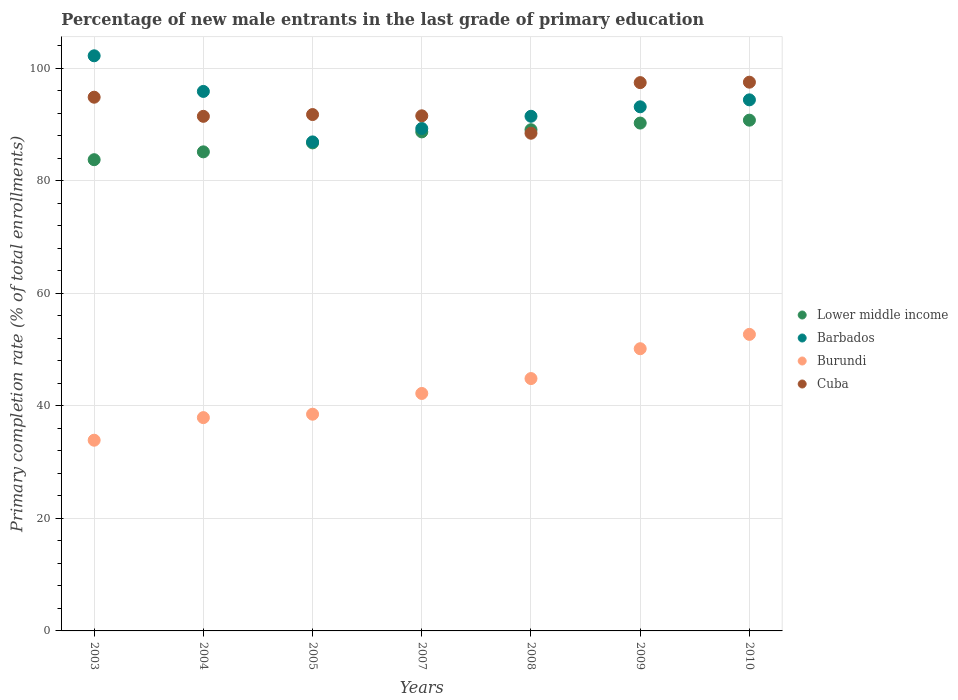Is the number of dotlines equal to the number of legend labels?
Your response must be concise. Yes. What is the percentage of new male entrants in Burundi in 2003?
Offer a terse response. 33.89. Across all years, what is the maximum percentage of new male entrants in Lower middle income?
Keep it short and to the point. 90.78. Across all years, what is the minimum percentage of new male entrants in Burundi?
Your answer should be very brief. 33.89. In which year was the percentage of new male entrants in Lower middle income minimum?
Offer a terse response. 2003. What is the total percentage of new male entrants in Burundi in the graph?
Keep it short and to the point. 300.24. What is the difference between the percentage of new male entrants in Burundi in 2003 and that in 2010?
Offer a very short reply. -18.81. What is the difference between the percentage of new male entrants in Lower middle income in 2004 and the percentage of new male entrants in Burundi in 2009?
Provide a short and direct response. 34.99. What is the average percentage of new male entrants in Lower middle income per year?
Your response must be concise. 87.78. In the year 2010, what is the difference between the percentage of new male entrants in Cuba and percentage of new male entrants in Barbados?
Ensure brevity in your answer.  3.14. What is the ratio of the percentage of new male entrants in Barbados in 2003 to that in 2005?
Offer a terse response. 1.18. Is the percentage of new male entrants in Lower middle income in 2009 less than that in 2010?
Keep it short and to the point. Yes. Is the difference between the percentage of new male entrants in Cuba in 2008 and 2009 greater than the difference between the percentage of new male entrants in Barbados in 2008 and 2009?
Make the answer very short. No. What is the difference between the highest and the second highest percentage of new male entrants in Barbados?
Your answer should be compact. 6.33. What is the difference between the highest and the lowest percentage of new male entrants in Lower middle income?
Provide a short and direct response. 7.03. In how many years, is the percentage of new male entrants in Cuba greater than the average percentage of new male entrants in Cuba taken over all years?
Your answer should be very brief. 3. Is the sum of the percentage of new male entrants in Barbados in 2007 and 2009 greater than the maximum percentage of new male entrants in Burundi across all years?
Provide a succinct answer. Yes. Is it the case that in every year, the sum of the percentage of new male entrants in Cuba and percentage of new male entrants in Barbados  is greater than the sum of percentage of new male entrants in Burundi and percentage of new male entrants in Lower middle income?
Provide a succinct answer. No. Is the percentage of new male entrants in Cuba strictly less than the percentage of new male entrants in Lower middle income over the years?
Provide a short and direct response. No. What is the difference between two consecutive major ticks on the Y-axis?
Give a very brief answer. 20. How many legend labels are there?
Your response must be concise. 4. How are the legend labels stacked?
Your answer should be compact. Vertical. What is the title of the graph?
Make the answer very short. Percentage of new male entrants in the last grade of primary education. What is the label or title of the X-axis?
Your response must be concise. Years. What is the label or title of the Y-axis?
Provide a succinct answer. Primary completion rate (% of total enrollments). What is the Primary completion rate (% of total enrollments) of Lower middle income in 2003?
Make the answer very short. 83.75. What is the Primary completion rate (% of total enrollments) in Barbados in 2003?
Ensure brevity in your answer.  102.22. What is the Primary completion rate (% of total enrollments) of Burundi in 2003?
Provide a succinct answer. 33.89. What is the Primary completion rate (% of total enrollments) of Cuba in 2003?
Provide a succinct answer. 94.86. What is the Primary completion rate (% of total enrollments) in Lower middle income in 2004?
Make the answer very short. 85.15. What is the Primary completion rate (% of total enrollments) in Barbados in 2004?
Provide a succinct answer. 95.89. What is the Primary completion rate (% of total enrollments) in Burundi in 2004?
Provide a succinct answer. 37.91. What is the Primary completion rate (% of total enrollments) of Cuba in 2004?
Ensure brevity in your answer.  91.46. What is the Primary completion rate (% of total enrollments) of Lower middle income in 2005?
Your answer should be compact. 86.74. What is the Primary completion rate (% of total enrollments) of Barbados in 2005?
Give a very brief answer. 86.92. What is the Primary completion rate (% of total enrollments) in Burundi in 2005?
Provide a succinct answer. 38.52. What is the Primary completion rate (% of total enrollments) of Cuba in 2005?
Your response must be concise. 91.78. What is the Primary completion rate (% of total enrollments) of Lower middle income in 2007?
Provide a succinct answer. 88.69. What is the Primary completion rate (% of total enrollments) of Barbados in 2007?
Provide a succinct answer. 89.3. What is the Primary completion rate (% of total enrollments) in Burundi in 2007?
Keep it short and to the point. 42.21. What is the Primary completion rate (% of total enrollments) of Cuba in 2007?
Ensure brevity in your answer.  91.55. What is the Primary completion rate (% of total enrollments) in Lower middle income in 2008?
Your answer should be very brief. 89.08. What is the Primary completion rate (% of total enrollments) in Barbados in 2008?
Your answer should be very brief. 91.47. What is the Primary completion rate (% of total enrollments) of Burundi in 2008?
Provide a short and direct response. 44.85. What is the Primary completion rate (% of total enrollments) in Cuba in 2008?
Your answer should be compact. 88.46. What is the Primary completion rate (% of total enrollments) in Lower middle income in 2009?
Make the answer very short. 90.26. What is the Primary completion rate (% of total enrollments) of Barbados in 2009?
Ensure brevity in your answer.  93.15. What is the Primary completion rate (% of total enrollments) of Burundi in 2009?
Keep it short and to the point. 50.16. What is the Primary completion rate (% of total enrollments) of Cuba in 2009?
Keep it short and to the point. 97.45. What is the Primary completion rate (% of total enrollments) of Lower middle income in 2010?
Offer a very short reply. 90.78. What is the Primary completion rate (% of total enrollments) of Barbados in 2010?
Offer a terse response. 94.39. What is the Primary completion rate (% of total enrollments) in Burundi in 2010?
Your answer should be compact. 52.71. What is the Primary completion rate (% of total enrollments) in Cuba in 2010?
Provide a short and direct response. 97.53. Across all years, what is the maximum Primary completion rate (% of total enrollments) of Lower middle income?
Provide a succinct answer. 90.78. Across all years, what is the maximum Primary completion rate (% of total enrollments) in Barbados?
Give a very brief answer. 102.22. Across all years, what is the maximum Primary completion rate (% of total enrollments) of Burundi?
Your response must be concise. 52.71. Across all years, what is the maximum Primary completion rate (% of total enrollments) in Cuba?
Give a very brief answer. 97.53. Across all years, what is the minimum Primary completion rate (% of total enrollments) in Lower middle income?
Your answer should be very brief. 83.75. Across all years, what is the minimum Primary completion rate (% of total enrollments) of Barbados?
Make the answer very short. 86.92. Across all years, what is the minimum Primary completion rate (% of total enrollments) of Burundi?
Your answer should be very brief. 33.89. Across all years, what is the minimum Primary completion rate (% of total enrollments) of Cuba?
Provide a short and direct response. 88.46. What is the total Primary completion rate (% of total enrollments) of Lower middle income in the graph?
Provide a succinct answer. 614.46. What is the total Primary completion rate (% of total enrollments) in Barbados in the graph?
Give a very brief answer. 653.33. What is the total Primary completion rate (% of total enrollments) in Burundi in the graph?
Offer a terse response. 300.24. What is the total Primary completion rate (% of total enrollments) in Cuba in the graph?
Your answer should be compact. 653.08. What is the difference between the Primary completion rate (% of total enrollments) of Lower middle income in 2003 and that in 2004?
Keep it short and to the point. -1.39. What is the difference between the Primary completion rate (% of total enrollments) in Barbados in 2003 and that in 2004?
Provide a succinct answer. 6.33. What is the difference between the Primary completion rate (% of total enrollments) in Burundi in 2003 and that in 2004?
Make the answer very short. -4.02. What is the difference between the Primary completion rate (% of total enrollments) of Cuba in 2003 and that in 2004?
Ensure brevity in your answer.  3.4. What is the difference between the Primary completion rate (% of total enrollments) of Lower middle income in 2003 and that in 2005?
Your answer should be very brief. -2.99. What is the difference between the Primary completion rate (% of total enrollments) of Barbados in 2003 and that in 2005?
Offer a very short reply. 15.3. What is the difference between the Primary completion rate (% of total enrollments) of Burundi in 2003 and that in 2005?
Your response must be concise. -4.62. What is the difference between the Primary completion rate (% of total enrollments) in Cuba in 2003 and that in 2005?
Give a very brief answer. 3.08. What is the difference between the Primary completion rate (% of total enrollments) in Lower middle income in 2003 and that in 2007?
Provide a short and direct response. -4.94. What is the difference between the Primary completion rate (% of total enrollments) in Barbados in 2003 and that in 2007?
Give a very brief answer. 12.92. What is the difference between the Primary completion rate (% of total enrollments) of Burundi in 2003 and that in 2007?
Ensure brevity in your answer.  -8.31. What is the difference between the Primary completion rate (% of total enrollments) of Cuba in 2003 and that in 2007?
Offer a terse response. 3.31. What is the difference between the Primary completion rate (% of total enrollments) of Lower middle income in 2003 and that in 2008?
Your answer should be very brief. -5.33. What is the difference between the Primary completion rate (% of total enrollments) of Barbados in 2003 and that in 2008?
Your answer should be compact. 10.75. What is the difference between the Primary completion rate (% of total enrollments) of Burundi in 2003 and that in 2008?
Provide a succinct answer. -10.96. What is the difference between the Primary completion rate (% of total enrollments) in Cuba in 2003 and that in 2008?
Offer a very short reply. 6.4. What is the difference between the Primary completion rate (% of total enrollments) in Lower middle income in 2003 and that in 2009?
Ensure brevity in your answer.  -6.51. What is the difference between the Primary completion rate (% of total enrollments) in Barbados in 2003 and that in 2009?
Provide a succinct answer. 9.07. What is the difference between the Primary completion rate (% of total enrollments) of Burundi in 2003 and that in 2009?
Offer a terse response. -16.26. What is the difference between the Primary completion rate (% of total enrollments) of Cuba in 2003 and that in 2009?
Provide a short and direct response. -2.59. What is the difference between the Primary completion rate (% of total enrollments) of Lower middle income in 2003 and that in 2010?
Make the answer very short. -7.03. What is the difference between the Primary completion rate (% of total enrollments) in Barbados in 2003 and that in 2010?
Provide a succinct answer. 7.83. What is the difference between the Primary completion rate (% of total enrollments) of Burundi in 2003 and that in 2010?
Keep it short and to the point. -18.81. What is the difference between the Primary completion rate (% of total enrollments) in Cuba in 2003 and that in 2010?
Ensure brevity in your answer.  -2.67. What is the difference between the Primary completion rate (% of total enrollments) in Lower middle income in 2004 and that in 2005?
Ensure brevity in your answer.  -1.59. What is the difference between the Primary completion rate (% of total enrollments) in Barbados in 2004 and that in 2005?
Your answer should be very brief. 8.97. What is the difference between the Primary completion rate (% of total enrollments) of Burundi in 2004 and that in 2005?
Make the answer very short. -0.61. What is the difference between the Primary completion rate (% of total enrollments) of Cuba in 2004 and that in 2005?
Offer a terse response. -0.32. What is the difference between the Primary completion rate (% of total enrollments) of Lower middle income in 2004 and that in 2007?
Offer a terse response. -3.55. What is the difference between the Primary completion rate (% of total enrollments) in Barbados in 2004 and that in 2007?
Your response must be concise. 6.59. What is the difference between the Primary completion rate (% of total enrollments) of Burundi in 2004 and that in 2007?
Provide a succinct answer. -4.29. What is the difference between the Primary completion rate (% of total enrollments) in Cuba in 2004 and that in 2007?
Provide a short and direct response. -0.09. What is the difference between the Primary completion rate (% of total enrollments) in Lower middle income in 2004 and that in 2008?
Keep it short and to the point. -3.93. What is the difference between the Primary completion rate (% of total enrollments) of Barbados in 2004 and that in 2008?
Keep it short and to the point. 4.42. What is the difference between the Primary completion rate (% of total enrollments) of Burundi in 2004 and that in 2008?
Ensure brevity in your answer.  -6.94. What is the difference between the Primary completion rate (% of total enrollments) in Cuba in 2004 and that in 2008?
Offer a terse response. 3. What is the difference between the Primary completion rate (% of total enrollments) in Lower middle income in 2004 and that in 2009?
Ensure brevity in your answer.  -5.12. What is the difference between the Primary completion rate (% of total enrollments) in Barbados in 2004 and that in 2009?
Provide a succinct answer. 2.74. What is the difference between the Primary completion rate (% of total enrollments) in Burundi in 2004 and that in 2009?
Make the answer very short. -12.25. What is the difference between the Primary completion rate (% of total enrollments) in Cuba in 2004 and that in 2009?
Give a very brief answer. -5.99. What is the difference between the Primary completion rate (% of total enrollments) of Lower middle income in 2004 and that in 2010?
Keep it short and to the point. -5.63. What is the difference between the Primary completion rate (% of total enrollments) in Barbados in 2004 and that in 2010?
Provide a succinct answer. 1.5. What is the difference between the Primary completion rate (% of total enrollments) in Burundi in 2004 and that in 2010?
Offer a very short reply. -14.8. What is the difference between the Primary completion rate (% of total enrollments) of Cuba in 2004 and that in 2010?
Make the answer very short. -6.07. What is the difference between the Primary completion rate (% of total enrollments) of Lower middle income in 2005 and that in 2007?
Your response must be concise. -1.95. What is the difference between the Primary completion rate (% of total enrollments) in Barbados in 2005 and that in 2007?
Provide a succinct answer. -2.38. What is the difference between the Primary completion rate (% of total enrollments) of Burundi in 2005 and that in 2007?
Keep it short and to the point. -3.69. What is the difference between the Primary completion rate (% of total enrollments) in Cuba in 2005 and that in 2007?
Your response must be concise. 0.22. What is the difference between the Primary completion rate (% of total enrollments) of Lower middle income in 2005 and that in 2008?
Offer a terse response. -2.34. What is the difference between the Primary completion rate (% of total enrollments) in Barbados in 2005 and that in 2008?
Your response must be concise. -4.55. What is the difference between the Primary completion rate (% of total enrollments) of Burundi in 2005 and that in 2008?
Offer a very short reply. -6.33. What is the difference between the Primary completion rate (% of total enrollments) of Cuba in 2005 and that in 2008?
Give a very brief answer. 3.32. What is the difference between the Primary completion rate (% of total enrollments) in Lower middle income in 2005 and that in 2009?
Offer a terse response. -3.52. What is the difference between the Primary completion rate (% of total enrollments) of Barbados in 2005 and that in 2009?
Your answer should be compact. -6.24. What is the difference between the Primary completion rate (% of total enrollments) of Burundi in 2005 and that in 2009?
Your response must be concise. -11.64. What is the difference between the Primary completion rate (% of total enrollments) of Cuba in 2005 and that in 2009?
Provide a succinct answer. -5.68. What is the difference between the Primary completion rate (% of total enrollments) of Lower middle income in 2005 and that in 2010?
Give a very brief answer. -4.04. What is the difference between the Primary completion rate (% of total enrollments) in Barbados in 2005 and that in 2010?
Make the answer very short. -7.47. What is the difference between the Primary completion rate (% of total enrollments) in Burundi in 2005 and that in 2010?
Your response must be concise. -14.19. What is the difference between the Primary completion rate (% of total enrollments) in Cuba in 2005 and that in 2010?
Make the answer very short. -5.75. What is the difference between the Primary completion rate (% of total enrollments) in Lower middle income in 2007 and that in 2008?
Keep it short and to the point. -0.39. What is the difference between the Primary completion rate (% of total enrollments) of Barbados in 2007 and that in 2008?
Your answer should be very brief. -2.17. What is the difference between the Primary completion rate (% of total enrollments) of Burundi in 2007 and that in 2008?
Make the answer very short. -2.65. What is the difference between the Primary completion rate (% of total enrollments) of Cuba in 2007 and that in 2008?
Ensure brevity in your answer.  3.09. What is the difference between the Primary completion rate (% of total enrollments) of Lower middle income in 2007 and that in 2009?
Offer a very short reply. -1.57. What is the difference between the Primary completion rate (% of total enrollments) in Barbados in 2007 and that in 2009?
Your answer should be compact. -3.86. What is the difference between the Primary completion rate (% of total enrollments) of Burundi in 2007 and that in 2009?
Provide a short and direct response. -7.95. What is the difference between the Primary completion rate (% of total enrollments) in Cuba in 2007 and that in 2009?
Offer a very short reply. -5.9. What is the difference between the Primary completion rate (% of total enrollments) of Lower middle income in 2007 and that in 2010?
Your response must be concise. -2.08. What is the difference between the Primary completion rate (% of total enrollments) in Barbados in 2007 and that in 2010?
Offer a terse response. -5.09. What is the difference between the Primary completion rate (% of total enrollments) of Burundi in 2007 and that in 2010?
Offer a very short reply. -10.5. What is the difference between the Primary completion rate (% of total enrollments) in Cuba in 2007 and that in 2010?
Keep it short and to the point. -5.98. What is the difference between the Primary completion rate (% of total enrollments) of Lower middle income in 2008 and that in 2009?
Your answer should be very brief. -1.18. What is the difference between the Primary completion rate (% of total enrollments) of Barbados in 2008 and that in 2009?
Your answer should be compact. -1.68. What is the difference between the Primary completion rate (% of total enrollments) of Burundi in 2008 and that in 2009?
Ensure brevity in your answer.  -5.3. What is the difference between the Primary completion rate (% of total enrollments) of Cuba in 2008 and that in 2009?
Offer a very short reply. -9. What is the difference between the Primary completion rate (% of total enrollments) of Lower middle income in 2008 and that in 2010?
Make the answer very short. -1.7. What is the difference between the Primary completion rate (% of total enrollments) in Barbados in 2008 and that in 2010?
Make the answer very short. -2.92. What is the difference between the Primary completion rate (% of total enrollments) of Burundi in 2008 and that in 2010?
Ensure brevity in your answer.  -7.85. What is the difference between the Primary completion rate (% of total enrollments) of Cuba in 2008 and that in 2010?
Make the answer very short. -9.07. What is the difference between the Primary completion rate (% of total enrollments) of Lower middle income in 2009 and that in 2010?
Make the answer very short. -0.52. What is the difference between the Primary completion rate (% of total enrollments) in Barbados in 2009 and that in 2010?
Make the answer very short. -1.24. What is the difference between the Primary completion rate (% of total enrollments) of Burundi in 2009 and that in 2010?
Give a very brief answer. -2.55. What is the difference between the Primary completion rate (% of total enrollments) in Cuba in 2009 and that in 2010?
Your answer should be compact. -0.08. What is the difference between the Primary completion rate (% of total enrollments) in Lower middle income in 2003 and the Primary completion rate (% of total enrollments) in Barbados in 2004?
Provide a succinct answer. -12.13. What is the difference between the Primary completion rate (% of total enrollments) of Lower middle income in 2003 and the Primary completion rate (% of total enrollments) of Burundi in 2004?
Offer a terse response. 45.84. What is the difference between the Primary completion rate (% of total enrollments) of Lower middle income in 2003 and the Primary completion rate (% of total enrollments) of Cuba in 2004?
Provide a succinct answer. -7.71. What is the difference between the Primary completion rate (% of total enrollments) in Barbados in 2003 and the Primary completion rate (% of total enrollments) in Burundi in 2004?
Make the answer very short. 64.31. What is the difference between the Primary completion rate (% of total enrollments) of Barbados in 2003 and the Primary completion rate (% of total enrollments) of Cuba in 2004?
Keep it short and to the point. 10.76. What is the difference between the Primary completion rate (% of total enrollments) in Burundi in 2003 and the Primary completion rate (% of total enrollments) in Cuba in 2004?
Your response must be concise. -57.57. What is the difference between the Primary completion rate (% of total enrollments) of Lower middle income in 2003 and the Primary completion rate (% of total enrollments) of Barbados in 2005?
Make the answer very short. -3.16. What is the difference between the Primary completion rate (% of total enrollments) of Lower middle income in 2003 and the Primary completion rate (% of total enrollments) of Burundi in 2005?
Your response must be concise. 45.23. What is the difference between the Primary completion rate (% of total enrollments) in Lower middle income in 2003 and the Primary completion rate (% of total enrollments) in Cuba in 2005?
Your answer should be compact. -8.02. What is the difference between the Primary completion rate (% of total enrollments) in Barbados in 2003 and the Primary completion rate (% of total enrollments) in Burundi in 2005?
Give a very brief answer. 63.7. What is the difference between the Primary completion rate (% of total enrollments) in Barbados in 2003 and the Primary completion rate (% of total enrollments) in Cuba in 2005?
Your response must be concise. 10.44. What is the difference between the Primary completion rate (% of total enrollments) in Burundi in 2003 and the Primary completion rate (% of total enrollments) in Cuba in 2005?
Your answer should be compact. -57.88. What is the difference between the Primary completion rate (% of total enrollments) of Lower middle income in 2003 and the Primary completion rate (% of total enrollments) of Barbados in 2007?
Your answer should be compact. -5.54. What is the difference between the Primary completion rate (% of total enrollments) of Lower middle income in 2003 and the Primary completion rate (% of total enrollments) of Burundi in 2007?
Ensure brevity in your answer.  41.55. What is the difference between the Primary completion rate (% of total enrollments) in Lower middle income in 2003 and the Primary completion rate (% of total enrollments) in Cuba in 2007?
Your response must be concise. -7.8. What is the difference between the Primary completion rate (% of total enrollments) in Barbados in 2003 and the Primary completion rate (% of total enrollments) in Burundi in 2007?
Give a very brief answer. 60.01. What is the difference between the Primary completion rate (% of total enrollments) in Barbados in 2003 and the Primary completion rate (% of total enrollments) in Cuba in 2007?
Your answer should be very brief. 10.67. What is the difference between the Primary completion rate (% of total enrollments) in Burundi in 2003 and the Primary completion rate (% of total enrollments) in Cuba in 2007?
Give a very brief answer. -57.66. What is the difference between the Primary completion rate (% of total enrollments) in Lower middle income in 2003 and the Primary completion rate (% of total enrollments) in Barbados in 2008?
Make the answer very short. -7.72. What is the difference between the Primary completion rate (% of total enrollments) in Lower middle income in 2003 and the Primary completion rate (% of total enrollments) in Burundi in 2008?
Give a very brief answer. 38.9. What is the difference between the Primary completion rate (% of total enrollments) in Lower middle income in 2003 and the Primary completion rate (% of total enrollments) in Cuba in 2008?
Your answer should be compact. -4.7. What is the difference between the Primary completion rate (% of total enrollments) of Barbados in 2003 and the Primary completion rate (% of total enrollments) of Burundi in 2008?
Ensure brevity in your answer.  57.37. What is the difference between the Primary completion rate (% of total enrollments) in Barbados in 2003 and the Primary completion rate (% of total enrollments) in Cuba in 2008?
Offer a very short reply. 13.76. What is the difference between the Primary completion rate (% of total enrollments) in Burundi in 2003 and the Primary completion rate (% of total enrollments) in Cuba in 2008?
Make the answer very short. -54.56. What is the difference between the Primary completion rate (% of total enrollments) in Lower middle income in 2003 and the Primary completion rate (% of total enrollments) in Barbados in 2009?
Offer a terse response. -9.4. What is the difference between the Primary completion rate (% of total enrollments) of Lower middle income in 2003 and the Primary completion rate (% of total enrollments) of Burundi in 2009?
Your response must be concise. 33.59. What is the difference between the Primary completion rate (% of total enrollments) in Lower middle income in 2003 and the Primary completion rate (% of total enrollments) in Cuba in 2009?
Keep it short and to the point. -13.7. What is the difference between the Primary completion rate (% of total enrollments) in Barbados in 2003 and the Primary completion rate (% of total enrollments) in Burundi in 2009?
Provide a short and direct response. 52.06. What is the difference between the Primary completion rate (% of total enrollments) of Barbados in 2003 and the Primary completion rate (% of total enrollments) of Cuba in 2009?
Your response must be concise. 4.77. What is the difference between the Primary completion rate (% of total enrollments) in Burundi in 2003 and the Primary completion rate (% of total enrollments) in Cuba in 2009?
Your answer should be compact. -63.56. What is the difference between the Primary completion rate (% of total enrollments) in Lower middle income in 2003 and the Primary completion rate (% of total enrollments) in Barbados in 2010?
Make the answer very short. -10.64. What is the difference between the Primary completion rate (% of total enrollments) of Lower middle income in 2003 and the Primary completion rate (% of total enrollments) of Burundi in 2010?
Keep it short and to the point. 31.05. What is the difference between the Primary completion rate (% of total enrollments) of Lower middle income in 2003 and the Primary completion rate (% of total enrollments) of Cuba in 2010?
Keep it short and to the point. -13.78. What is the difference between the Primary completion rate (% of total enrollments) of Barbados in 2003 and the Primary completion rate (% of total enrollments) of Burundi in 2010?
Provide a short and direct response. 49.51. What is the difference between the Primary completion rate (% of total enrollments) in Barbados in 2003 and the Primary completion rate (% of total enrollments) in Cuba in 2010?
Provide a short and direct response. 4.69. What is the difference between the Primary completion rate (% of total enrollments) in Burundi in 2003 and the Primary completion rate (% of total enrollments) in Cuba in 2010?
Offer a terse response. -63.63. What is the difference between the Primary completion rate (% of total enrollments) of Lower middle income in 2004 and the Primary completion rate (% of total enrollments) of Barbados in 2005?
Keep it short and to the point. -1.77. What is the difference between the Primary completion rate (% of total enrollments) in Lower middle income in 2004 and the Primary completion rate (% of total enrollments) in Burundi in 2005?
Give a very brief answer. 46.63. What is the difference between the Primary completion rate (% of total enrollments) in Lower middle income in 2004 and the Primary completion rate (% of total enrollments) in Cuba in 2005?
Give a very brief answer. -6.63. What is the difference between the Primary completion rate (% of total enrollments) of Barbados in 2004 and the Primary completion rate (% of total enrollments) of Burundi in 2005?
Keep it short and to the point. 57.37. What is the difference between the Primary completion rate (% of total enrollments) in Barbados in 2004 and the Primary completion rate (% of total enrollments) in Cuba in 2005?
Keep it short and to the point. 4.11. What is the difference between the Primary completion rate (% of total enrollments) of Burundi in 2004 and the Primary completion rate (% of total enrollments) of Cuba in 2005?
Give a very brief answer. -53.86. What is the difference between the Primary completion rate (% of total enrollments) in Lower middle income in 2004 and the Primary completion rate (% of total enrollments) in Barbados in 2007?
Your answer should be compact. -4.15. What is the difference between the Primary completion rate (% of total enrollments) in Lower middle income in 2004 and the Primary completion rate (% of total enrollments) in Burundi in 2007?
Offer a very short reply. 42.94. What is the difference between the Primary completion rate (% of total enrollments) of Lower middle income in 2004 and the Primary completion rate (% of total enrollments) of Cuba in 2007?
Keep it short and to the point. -6.4. What is the difference between the Primary completion rate (% of total enrollments) of Barbados in 2004 and the Primary completion rate (% of total enrollments) of Burundi in 2007?
Offer a terse response. 53.68. What is the difference between the Primary completion rate (% of total enrollments) of Barbados in 2004 and the Primary completion rate (% of total enrollments) of Cuba in 2007?
Your response must be concise. 4.34. What is the difference between the Primary completion rate (% of total enrollments) in Burundi in 2004 and the Primary completion rate (% of total enrollments) in Cuba in 2007?
Offer a very short reply. -53.64. What is the difference between the Primary completion rate (% of total enrollments) in Lower middle income in 2004 and the Primary completion rate (% of total enrollments) in Barbados in 2008?
Provide a short and direct response. -6.32. What is the difference between the Primary completion rate (% of total enrollments) in Lower middle income in 2004 and the Primary completion rate (% of total enrollments) in Burundi in 2008?
Keep it short and to the point. 40.29. What is the difference between the Primary completion rate (% of total enrollments) of Lower middle income in 2004 and the Primary completion rate (% of total enrollments) of Cuba in 2008?
Give a very brief answer. -3.31. What is the difference between the Primary completion rate (% of total enrollments) in Barbados in 2004 and the Primary completion rate (% of total enrollments) in Burundi in 2008?
Make the answer very short. 51.03. What is the difference between the Primary completion rate (% of total enrollments) in Barbados in 2004 and the Primary completion rate (% of total enrollments) in Cuba in 2008?
Provide a short and direct response. 7.43. What is the difference between the Primary completion rate (% of total enrollments) of Burundi in 2004 and the Primary completion rate (% of total enrollments) of Cuba in 2008?
Your response must be concise. -50.55. What is the difference between the Primary completion rate (% of total enrollments) in Lower middle income in 2004 and the Primary completion rate (% of total enrollments) in Barbados in 2009?
Ensure brevity in your answer.  -8. What is the difference between the Primary completion rate (% of total enrollments) of Lower middle income in 2004 and the Primary completion rate (% of total enrollments) of Burundi in 2009?
Provide a succinct answer. 34.99. What is the difference between the Primary completion rate (% of total enrollments) of Lower middle income in 2004 and the Primary completion rate (% of total enrollments) of Cuba in 2009?
Offer a terse response. -12.31. What is the difference between the Primary completion rate (% of total enrollments) in Barbados in 2004 and the Primary completion rate (% of total enrollments) in Burundi in 2009?
Ensure brevity in your answer.  45.73. What is the difference between the Primary completion rate (% of total enrollments) in Barbados in 2004 and the Primary completion rate (% of total enrollments) in Cuba in 2009?
Ensure brevity in your answer.  -1.57. What is the difference between the Primary completion rate (% of total enrollments) in Burundi in 2004 and the Primary completion rate (% of total enrollments) in Cuba in 2009?
Your answer should be very brief. -59.54. What is the difference between the Primary completion rate (% of total enrollments) of Lower middle income in 2004 and the Primary completion rate (% of total enrollments) of Barbados in 2010?
Make the answer very short. -9.24. What is the difference between the Primary completion rate (% of total enrollments) of Lower middle income in 2004 and the Primary completion rate (% of total enrollments) of Burundi in 2010?
Give a very brief answer. 32.44. What is the difference between the Primary completion rate (% of total enrollments) in Lower middle income in 2004 and the Primary completion rate (% of total enrollments) in Cuba in 2010?
Provide a short and direct response. -12.38. What is the difference between the Primary completion rate (% of total enrollments) of Barbados in 2004 and the Primary completion rate (% of total enrollments) of Burundi in 2010?
Your response must be concise. 43.18. What is the difference between the Primary completion rate (% of total enrollments) of Barbados in 2004 and the Primary completion rate (% of total enrollments) of Cuba in 2010?
Your response must be concise. -1.64. What is the difference between the Primary completion rate (% of total enrollments) of Burundi in 2004 and the Primary completion rate (% of total enrollments) of Cuba in 2010?
Provide a succinct answer. -59.62. What is the difference between the Primary completion rate (% of total enrollments) of Lower middle income in 2005 and the Primary completion rate (% of total enrollments) of Barbados in 2007?
Ensure brevity in your answer.  -2.56. What is the difference between the Primary completion rate (% of total enrollments) in Lower middle income in 2005 and the Primary completion rate (% of total enrollments) in Burundi in 2007?
Keep it short and to the point. 44.54. What is the difference between the Primary completion rate (% of total enrollments) of Lower middle income in 2005 and the Primary completion rate (% of total enrollments) of Cuba in 2007?
Provide a succinct answer. -4.81. What is the difference between the Primary completion rate (% of total enrollments) in Barbados in 2005 and the Primary completion rate (% of total enrollments) in Burundi in 2007?
Your answer should be very brief. 44.71. What is the difference between the Primary completion rate (% of total enrollments) of Barbados in 2005 and the Primary completion rate (% of total enrollments) of Cuba in 2007?
Provide a succinct answer. -4.64. What is the difference between the Primary completion rate (% of total enrollments) of Burundi in 2005 and the Primary completion rate (% of total enrollments) of Cuba in 2007?
Offer a terse response. -53.03. What is the difference between the Primary completion rate (% of total enrollments) of Lower middle income in 2005 and the Primary completion rate (% of total enrollments) of Barbados in 2008?
Ensure brevity in your answer.  -4.73. What is the difference between the Primary completion rate (% of total enrollments) in Lower middle income in 2005 and the Primary completion rate (% of total enrollments) in Burundi in 2008?
Ensure brevity in your answer.  41.89. What is the difference between the Primary completion rate (% of total enrollments) of Lower middle income in 2005 and the Primary completion rate (% of total enrollments) of Cuba in 2008?
Provide a succinct answer. -1.72. What is the difference between the Primary completion rate (% of total enrollments) of Barbados in 2005 and the Primary completion rate (% of total enrollments) of Burundi in 2008?
Your response must be concise. 42.06. What is the difference between the Primary completion rate (% of total enrollments) in Barbados in 2005 and the Primary completion rate (% of total enrollments) in Cuba in 2008?
Your answer should be compact. -1.54. What is the difference between the Primary completion rate (% of total enrollments) of Burundi in 2005 and the Primary completion rate (% of total enrollments) of Cuba in 2008?
Keep it short and to the point. -49.94. What is the difference between the Primary completion rate (% of total enrollments) of Lower middle income in 2005 and the Primary completion rate (% of total enrollments) of Barbados in 2009?
Provide a succinct answer. -6.41. What is the difference between the Primary completion rate (% of total enrollments) of Lower middle income in 2005 and the Primary completion rate (% of total enrollments) of Burundi in 2009?
Keep it short and to the point. 36.58. What is the difference between the Primary completion rate (% of total enrollments) of Lower middle income in 2005 and the Primary completion rate (% of total enrollments) of Cuba in 2009?
Offer a very short reply. -10.71. What is the difference between the Primary completion rate (% of total enrollments) in Barbados in 2005 and the Primary completion rate (% of total enrollments) in Burundi in 2009?
Make the answer very short. 36.76. What is the difference between the Primary completion rate (% of total enrollments) in Barbados in 2005 and the Primary completion rate (% of total enrollments) in Cuba in 2009?
Your answer should be compact. -10.54. What is the difference between the Primary completion rate (% of total enrollments) of Burundi in 2005 and the Primary completion rate (% of total enrollments) of Cuba in 2009?
Offer a terse response. -58.93. What is the difference between the Primary completion rate (% of total enrollments) in Lower middle income in 2005 and the Primary completion rate (% of total enrollments) in Barbados in 2010?
Give a very brief answer. -7.65. What is the difference between the Primary completion rate (% of total enrollments) of Lower middle income in 2005 and the Primary completion rate (% of total enrollments) of Burundi in 2010?
Provide a short and direct response. 34.03. What is the difference between the Primary completion rate (% of total enrollments) in Lower middle income in 2005 and the Primary completion rate (% of total enrollments) in Cuba in 2010?
Keep it short and to the point. -10.79. What is the difference between the Primary completion rate (% of total enrollments) of Barbados in 2005 and the Primary completion rate (% of total enrollments) of Burundi in 2010?
Provide a succinct answer. 34.21. What is the difference between the Primary completion rate (% of total enrollments) in Barbados in 2005 and the Primary completion rate (% of total enrollments) in Cuba in 2010?
Offer a very short reply. -10.61. What is the difference between the Primary completion rate (% of total enrollments) in Burundi in 2005 and the Primary completion rate (% of total enrollments) in Cuba in 2010?
Provide a short and direct response. -59.01. What is the difference between the Primary completion rate (% of total enrollments) of Lower middle income in 2007 and the Primary completion rate (% of total enrollments) of Barbados in 2008?
Your response must be concise. -2.77. What is the difference between the Primary completion rate (% of total enrollments) of Lower middle income in 2007 and the Primary completion rate (% of total enrollments) of Burundi in 2008?
Your response must be concise. 43.84. What is the difference between the Primary completion rate (% of total enrollments) in Lower middle income in 2007 and the Primary completion rate (% of total enrollments) in Cuba in 2008?
Provide a short and direct response. 0.24. What is the difference between the Primary completion rate (% of total enrollments) in Barbados in 2007 and the Primary completion rate (% of total enrollments) in Burundi in 2008?
Offer a very short reply. 44.44. What is the difference between the Primary completion rate (% of total enrollments) in Barbados in 2007 and the Primary completion rate (% of total enrollments) in Cuba in 2008?
Your answer should be compact. 0.84. What is the difference between the Primary completion rate (% of total enrollments) of Burundi in 2007 and the Primary completion rate (% of total enrollments) of Cuba in 2008?
Keep it short and to the point. -46.25. What is the difference between the Primary completion rate (% of total enrollments) of Lower middle income in 2007 and the Primary completion rate (% of total enrollments) of Barbados in 2009?
Offer a very short reply. -4.46. What is the difference between the Primary completion rate (% of total enrollments) of Lower middle income in 2007 and the Primary completion rate (% of total enrollments) of Burundi in 2009?
Your answer should be compact. 38.54. What is the difference between the Primary completion rate (% of total enrollments) in Lower middle income in 2007 and the Primary completion rate (% of total enrollments) in Cuba in 2009?
Make the answer very short. -8.76. What is the difference between the Primary completion rate (% of total enrollments) in Barbados in 2007 and the Primary completion rate (% of total enrollments) in Burundi in 2009?
Provide a short and direct response. 39.14. What is the difference between the Primary completion rate (% of total enrollments) in Barbados in 2007 and the Primary completion rate (% of total enrollments) in Cuba in 2009?
Give a very brief answer. -8.16. What is the difference between the Primary completion rate (% of total enrollments) of Burundi in 2007 and the Primary completion rate (% of total enrollments) of Cuba in 2009?
Keep it short and to the point. -55.25. What is the difference between the Primary completion rate (% of total enrollments) in Lower middle income in 2007 and the Primary completion rate (% of total enrollments) in Barbados in 2010?
Your answer should be very brief. -5.69. What is the difference between the Primary completion rate (% of total enrollments) in Lower middle income in 2007 and the Primary completion rate (% of total enrollments) in Burundi in 2010?
Provide a short and direct response. 35.99. What is the difference between the Primary completion rate (% of total enrollments) of Lower middle income in 2007 and the Primary completion rate (% of total enrollments) of Cuba in 2010?
Your response must be concise. -8.83. What is the difference between the Primary completion rate (% of total enrollments) in Barbados in 2007 and the Primary completion rate (% of total enrollments) in Burundi in 2010?
Provide a succinct answer. 36.59. What is the difference between the Primary completion rate (% of total enrollments) in Barbados in 2007 and the Primary completion rate (% of total enrollments) in Cuba in 2010?
Your answer should be very brief. -8.23. What is the difference between the Primary completion rate (% of total enrollments) in Burundi in 2007 and the Primary completion rate (% of total enrollments) in Cuba in 2010?
Keep it short and to the point. -55.32. What is the difference between the Primary completion rate (% of total enrollments) of Lower middle income in 2008 and the Primary completion rate (% of total enrollments) of Barbados in 2009?
Give a very brief answer. -4.07. What is the difference between the Primary completion rate (% of total enrollments) of Lower middle income in 2008 and the Primary completion rate (% of total enrollments) of Burundi in 2009?
Provide a succinct answer. 38.92. What is the difference between the Primary completion rate (% of total enrollments) in Lower middle income in 2008 and the Primary completion rate (% of total enrollments) in Cuba in 2009?
Offer a very short reply. -8.37. What is the difference between the Primary completion rate (% of total enrollments) of Barbados in 2008 and the Primary completion rate (% of total enrollments) of Burundi in 2009?
Make the answer very short. 41.31. What is the difference between the Primary completion rate (% of total enrollments) of Barbados in 2008 and the Primary completion rate (% of total enrollments) of Cuba in 2009?
Ensure brevity in your answer.  -5.98. What is the difference between the Primary completion rate (% of total enrollments) of Burundi in 2008 and the Primary completion rate (% of total enrollments) of Cuba in 2009?
Offer a terse response. -52.6. What is the difference between the Primary completion rate (% of total enrollments) of Lower middle income in 2008 and the Primary completion rate (% of total enrollments) of Barbados in 2010?
Ensure brevity in your answer.  -5.31. What is the difference between the Primary completion rate (% of total enrollments) of Lower middle income in 2008 and the Primary completion rate (% of total enrollments) of Burundi in 2010?
Give a very brief answer. 36.37. What is the difference between the Primary completion rate (% of total enrollments) in Lower middle income in 2008 and the Primary completion rate (% of total enrollments) in Cuba in 2010?
Ensure brevity in your answer.  -8.45. What is the difference between the Primary completion rate (% of total enrollments) in Barbados in 2008 and the Primary completion rate (% of total enrollments) in Burundi in 2010?
Ensure brevity in your answer.  38.76. What is the difference between the Primary completion rate (% of total enrollments) of Barbados in 2008 and the Primary completion rate (% of total enrollments) of Cuba in 2010?
Your answer should be compact. -6.06. What is the difference between the Primary completion rate (% of total enrollments) of Burundi in 2008 and the Primary completion rate (% of total enrollments) of Cuba in 2010?
Give a very brief answer. -52.68. What is the difference between the Primary completion rate (% of total enrollments) of Lower middle income in 2009 and the Primary completion rate (% of total enrollments) of Barbados in 2010?
Make the answer very short. -4.13. What is the difference between the Primary completion rate (% of total enrollments) of Lower middle income in 2009 and the Primary completion rate (% of total enrollments) of Burundi in 2010?
Your response must be concise. 37.56. What is the difference between the Primary completion rate (% of total enrollments) of Lower middle income in 2009 and the Primary completion rate (% of total enrollments) of Cuba in 2010?
Give a very brief answer. -7.27. What is the difference between the Primary completion rate (% of total enrollments) in Barbados in 2009 and the Primary completion rate (% of total enrollments) in Burundi in 2010?
Provide a short and direct response. 40.44. What is the difference between the Primary completion rate (% of total enrollments) of Barbados in 2009 and the Primary completion rate (% of total enrollments) of Cuba in 2010?
Make the answer very short. -4.38. What is the difference between the Primary completion rate (% of total enrollments) of Burundi in 2009 and the Primary completion rate (% of total enrollments) of Cuba in 2010?
Your answer should be very brief. -47.37. What is the average Primary completion rate (% of total enrollments) of Lower middle income per year?
Make the answer very short. 87.78. What is the average Primary completion rate (% of total enrollments) of Barbados per year?
Keep it short and to the point. 93.33. What is the average Primary completion rate (% of total enrollments) in Burundi per year?
Provide a succinct answer. 42.89. What is the average Primary completion rate (% of total enrollments) in Cuba per year?
Your response must be concise. 93.3. In the year 2003, what is the difference between the Primary completion rate (% of total enrollments) in Lower middle income and Primary completion rate (% of total enrollments) in Barbados?
Offer a very short reply. -18.47. In the year 2003, what is the difference between the Primary completion rate (% of total enrollments) in Lower middle income and Primary completion rate (% of total enrollments) in Burundi?
Keep it short and to the point. 49.86. In the year 2003, what is the difference between the Primary completion rate (% of total enrollments) of Lower middle income and Primary completion rate (% of total enrollments) of Cuba?
Your answer should be very brief. -11.11. In the year 2003, what is the difference between the Primary completion rate (% of total enrollments) of Barbados and Primary completion rate (% of total enrollments) of Burundi?
Your answer should be compact. 68.32. In the year 2003, what is the difference between the Primary completion rate (% of total enrollments) of Barbados and Primary completion rate (% of total enrollments) of Cuba?
Offer a terse response. 7.36. In the year 2003, what is the difference between the Primary completion rate (% of total enrollments) of Burundi and Primary completion rate (% of total enrollments) of Cuba?
Ensure brevity in your answer.  -60.96. In the year 2004, what is the difference between the Primary completion rate (% of total enrollments) of Lower middle income and Primary completion rate (% of total enrollments) of Barbados?
Your answer should be very brief. -10.74. In the year 2004, what is the difference between the Primary completion rate (% of total enrollments) of Lower middle income and Primary completion rate (% of total enrollments) of Burundi?
Make the answer very short. 47.24. In the year 2004, what is the difference between the Primary completion rate (% of total enrollments) in Lower middle income and Primary completion rate (% of total enrollments) in Cuba?
Ensure brevity in your answer.  -6.31. In the year 2004, what is the difference between the Primary completion rate (% of total enrollments) of Barbados and Primary completion rate (% of total enrollments) of Burundi?
Your response must be concise. 57.98. In the year 2004, what is the difference between the Primary completion rate (% of total enrollments) of Barbados and Primary completion rate (% of total enrollments) of Cuba?
Keep it short and to the point. 4.43. In the year 2004, what is the difference between the Primary completion rate (% of total enrollments) in Burundi and Primary completion rate (% of total enrollments) in Cuba?
Offer a terse response. -53.55. In the year 2005, what is the difference between the Primary completion rate (% of total enrollments) of Lower middle income and Primary completion rate (% of total enrollments) of Barbados?
Offer a terse response. -0.17. In the year 2005, what is the difference between the Primary completion rate (% of total enrollments) of Lower middle income and Primary completion rate (% of total enrollments) of Burundi?
Keep it short and to the point. 48.22. In the year 2005, what is the difference between the Primary completion rate (% of total enrollments) of Lower middle income and Primary completion rate (% of total enrollments) of Cuba?
Your answer should be compact. -5.03. In the year 2005, what is the difference between the Primary completion rate (% of total enrollments) of Barbados and Primary completion rate (% of total enrollments) of Burundi?
Keep it short and to the point. 48.4. In the year 2005, what is the difference between the Primary completion rate (% of total enrollments) in Barbados and Primary completion rate (% of total enrollments) in Cuba?
Your answer should be very brief. -4.86. In the year 2005, what is the difference between the Primary completion rate (% of total enrollments) of Burundi and Primary completion rate (% of total enrollments) of Cuba?
Keep it short and to the point. -53.26. In the year 2007, what is the difference between the Primary completion rate (% of total enrollments) of Lower middle income and Primary completion rate (% of total enrollments) of Barbados?
Provide a short and direct response. -0.6. In the year 2007, what is the difference between the Primary completion rate (% of total enrollments) in Lower middle income and Primary completion rate (% of total enrollments) in Burundi?
Your answer should be compact. 46.49. In the year 2007, what is the difference between the Primary completion rate (% of total enrollments) of Lower middle income and Primary completion rate (% of total enrollments) of Cuba?
Provide a short and direct response. -2.86. In the year 2007, what is the difference between the Primary completion rate (% of total enrollments) of Barbados and Primary completion rate (% of total enrollments) of Burundi?
Provide a short and direct response. 47.09. In the year 2007, what is the difference between the Primary completion rate (% of total enrollments) in Barbados and Primary completion rate (% of total enrollments) in Cuba?
Make the answer very short. -2.25. In the year 2007, what is the difference between the Primary completion rate (% of total enrollments) of Burundi and Primary completion rate (% of total enrollments) of Cuba?
Your answer should be compact. -49.35. In the year 2008, what is the difference between the Primary completion rate (% of total enrollments) in Lower middle income and Primary completion rate (% of total enrollments) in Barbados?
Provide a short and direct response. -2.39. In the year 2008, what is the difference between the Primary completion rate (% of total enrollments) in Lower middle income and Primary completion rate (% of total enrollments) in Burundi?
Keep it short and to the point. 44.23. In the year 2008, what is the difference between the Primary completion rate (% of total enrollments) of Lower middle income and Primary completion rate (% of total enrollments) of Cuba?
Your answer should be very brief. 0.62. In the year 2008, what is the difference between the Primary completion rate (% of total enrollments) in Barbados and Primary completion rate (% of total enrollments) in Burundi?
Keep it short and to the point. 46.62. In the year 2008, what is the difference between the Primary completion rate (% of total enrollments) of Barbados and Primary completion rate (% of total enrollments) of Cuba?
Your response must be concise. 3.01. In the year 2008, what is the difference between the Primary completion rate (% of total enrollments) in Burundi and Primary completion rate (% of total enrollments) in Cuba?
Your response must be concise. -43.6. In the year 2009, what is the difference between the Primary completion rate (% of total enrollments) in Lower middle income and Primary completion rate (% of total enrollments) in Barbados?
Provide a succinct answer. -2.89. In the year 2009, what is the difference between the Primary completion rate (% of total enrollments) of Lower middle income and Primary completion rate (% of total enrollments) of Burundi?
Offer a very short reply. 40.11. In the year 2009, what is the difference between the Primary completion rate (% of total enrollments) in Lower middle income and Primary completion rate (% of total enrollments) in Cuba?
Provide a short and direct response. -7.19. In the year 2009, what is the difference between the Primary completion rate (% of total enrollments) of Barbados and Primary completion rate (% of total enrollments) of Burundi?
Your answer should be compact. 42.99. In the year 2009, what is the difference between the Primary completion rate (% of total enrollments) of Barbados and Primary completion rate (% of total enrollments) of Cuba?
Offer a terse response. -4.3. In the year 2009, what is the difference between the Primary completion rate (% of total enrollments) in Burundi and Primary completion rate (% of total enrollments) in Cuba?
Provide a short and direct response. -47.3. In the year 2010, what is the difference between the Primary completion rate (% of total enrollments) of Lower middle income and Primary completion rate (% of total enrollments) of Barbados?
Your response must be concise. -3.61. In the year 2010, what is the difference between the Primary completion rate (% of total enrollments) of Lower middle income and Primary completion rate (% of total enrollments) of Burundi?
Ensure brevity in your answer.  38.07. In the year 2010, what is the difference between the Primary completion rate (% of total enrollments) of Lower middle income and Primary completion rate (% of total enrollments) of Cuba?
Ensure brevity in your answer.  -6.75. In the year 2010, what is the difference between the Primary completion rate (% of total enrollments) of Barbados and Primary completion rate (% of total enrollments) of Burundi?
Keep it short and to the point. 41.68. In the year 2010, what is the difference between the Primary completion rate (% of total enrollments) in Barbados and Primary completion rate (% of total enrollments) in Cuba?
Give a very brief answer. -3.14. In the year 2010, what is the difference between the Primary completion rate (% of total enrollments) of Burundi and Primary completion rate (% of total enrollments) of Cuba?
Provide a short and direct response. -44.82. What is the ratio of the Primary completion rate (% of total enrollments) of Lower middle income in 2003 to that in 2004?
Provide a succinct answer. 0.98. What is the ratio of the Primary completion rate (% of total enrollments) in Barbados in 2003 to that in 2004?
Ensure brevity in your answer.  1.07. What is the ratio of the Primary completion rate (% of total enrollments) in Burundi in 2003 to that in 2004?
Ensure brevity in your answer.  0.89. What is the ratio of the Primary completion rate (% of total enrollments) in Cuba in 2003 to that in 2004?
Provide a succinct answer. 1.04. What is the ratio of the Primary completion rate (% of total enrollments) of Lower middle income in 2003 to that in 2005?
Make the answer very short. 0.97. What is the ratio of the Primary completion rate (% of total enrollments) in Barbados in 2003 to that in 2005?
Provide a succinct answer. 1.18. What is the ratio of the Primary completion rate (% of total enrollments) in Cuba in 2003 to that in 2005?
Your answer should be very brief. 1.03. What is the ratio of the Primary completion rate (% of total enrollments) in Lower middle income in 2003 to that in 2007?
Provide a short and direct response. 0.94. What is the ratio of the Primary completion rate (% of total enrollments) of Barbados in 2003 to that in 2007?
Your answer should be compact. 1.14. What is the ratio of the Primary completion rate (% of total enrollments) of Burundi in 2003 to that in 2007?
Give a very brief answer. 0.8. What is the ratio of the Primary completion rate (% of total enrollments) of Cuba in 2003 to that in 2007?
Provide a short and direct response. 1.04. What is the ratio of the Primary completion rate (% of total enrollments) of Lower middle income in 2003 to that in 2008?
Ensure brevity in your answer.  0.94. What is the ratio of the Primary completion rate (% of total enrollments) of Barbados in 2003 to that in 2008?
Offer a terse response. 1.12. What is the ratio of the Primary completion rate (% of total enrollments) of Burundi in 2003 to that in 2008?
Your answer should be very brief. 0.76. What is the ratio of the Primary completion rate (% of total enrollments) of Cuba in 2003 to that in 2008?
Provide a succinct answer. 1.07. What is the ratio of the Primary completion rate (% of total enrollments) in Lower middle income in 2003 to that in 2009?
Provide a short and direct response. 0.93. What is the ratio of the Primary completion rate (% of total enrollments) of Barbados in 2003 to that in 2009?
Provide a short and direct response. 1.1. What is the ratio of the Primary completion rate (% of total enrollments) of Burundi in 2003 to that in 2009?
Your response must be concise. 0.68. What is the ratio of the Primary completion rate (% of total enrollments) of Cuba in 2003 to that in 2009?
Provide a succinct answer. 0.97. What is the ratio of the Primary completion rate (% of total enrollments) in Lower middle income in 2003 to that in 2010?
Your answer should be very brief. 0.92. What is the ratio of the Primary completion rate (% of total enrollments) of Barbados in 2003 to that in 2010?
Provide a succinct answer. 1.08. What is the ratio of the Primary completion rate (% of total enrollments) of Burundi in 2003 to that in 2010?
Offer a very short reply. 0.64. What is the ratio of the Primary completion rate (% of total enrollments) of Cuba in 2003 to that in 2010?
Keep it short and to the point. 0.97. What is the ratio of the Primary completion rate (% of total enrollments) in Lower middle income in 2004 to that in 2005?
Give a very brief answer. 0.98. What is the ratio of the Primary completion rate (% of total enrollments) of Barbados in 2004 to that in 2005?
Your answer should be very brief. 1.1. What is the ratio of the Primary completion rate (% of total enrollments) in Burundi in 2004 to that in 2005?
Make the answer very short. 0.98. What is the ratio of the Primary completion rate (% of total enrollments) of Lower middle income in 2004 to that in 2007?
Make the answer very short. 0.96. What is the ratio of the Primary completion rate (% of total enrollments) in Barbados in 2004 to that in 2007?
Offer a terse response. 1.07. What is the ratio of the Primary completion rate (% of total enrollments) in Burundi in 2004 to that in 2007?
Provide a short and direct response. 0.9. What is the ratio of the Primary completion rate (% of total enrollments) of Lower middle income in 2004 to that in 2008?
Provide a short and direct response. 0.96. What is the ratio of the Primary completion rate (% of total enrollments) of Barbados in 2004 to that in 2008?
Provide a succinct answer. 1.05. What is the ratio of the Primary completion rate (% of total enrollments) of Burundi in 2004 to that in 2008?
Offer a very short reply. 0.85. What is the ratio of the Primary completion rate (% of total enrollments) of Cuba in 2004 to that in 2008?
Ensure brevity in your answer.  1.03. What is the ratio of the Primary completion rate (% of total enrollments) in Lower middle income in 2004 to that in 2009?
Keep it short and to the point. 0.94. What is the ratio of the Primary completion rate (% of total enrollments) of Barbados in 2004 to that in 2009?
Offer a terse response. 1.03. What is the ratio of the Primary completion rate (% of total enrollments) of Burundi in 2004 to that in 2009?
Provide a short and direct response. 0.76. What is the ratio of the Primary completion rate (% of total enrollments) in Cuba in 2004 to that in 2009?
Provide a succinct answer. 0.94. What is the ratio of the Primary completion rate (% of total enrollments) in Lower middle income in 2004 to that in 2010?
Your answer should be compact. 0.94. What is the ratio of the Primary completion rate (% of total enrollments) in Barbados in 2004 to that in 2010?
Provide a short and direct response. 1.02. What is the ratio of the Primary completion rate (% of total enrollments) of Burundi in 2004 to that in 2010?
Offer a very short reply. 0.72. What is the ratio of the Primary completion rate (% of total enrollments) of Cuba in 2004 to that in 2010?
Your answer should be compact. 0.94. What is the ratio of the Primary completion rate (% of total enrollments) of Lower middle income in 2005 to that in 2007?
Your answer should be compact. 0.98. What is the ratio of the Primary completion rate (% of total enrollments) in Barbados in 2005 to that in 2007?
Offer a terse response. 0.97. What is the ratio of the Primary completion rate (% of total enrollments) in Burundi in 2005 to that in 2007?
Your response must be concise. 0.91. What is the ratio of the Primary completion rate (% of total enrollments) of Cuba in 2005 to that in 2007?
Give a very brief answer. 1. What is the ratio of the Primary completion rate (% of total enrollments) of Lower middle income in 2005 to that in 2008?
Make the answer very short. 0.97. What is the ratio of the Primary completion rate (% of total enrollments) in Barbados in 2005 to that in 2008?
Provide a succinct answer. 0.95. What is the ratio of the Primary completion rate (% of total enrollments) in Burundi in 2005 to that in 2008?
Your response must be concise. 0.86. What is the ratio of the Primary completion rate (% of total enrollments) in Cuba in 2005 to that in 2008?
Your answer should be compact. 1.04. What is the ratio of the Primary completion rate (% of total enrollments) of Lower middle income in 2005 to that in 2009?
Your response must be concise. 0.96. What is the ratio of the Primary completion rate (% of total enrollments) of Barbados in 2005 to that in 2009?
Make the answer very short. 0.93. What is the ratio of the Primary completion rate (% of total enrollments) of Burundi in 2005 to that in 2009?
Provide a short and direct response. 0.77. What is the ratio of the Primary completion rate (% of total enrollments) of Cuba in 2005 to that in 2009?
Offer a terse response. 0.94. What is the ratio of the Primary completion rate (% of total enrollments) in Lower middle income in 2005 to that in 2010?
Offer a terse response. 0.96. What is the ratio of the Primary completion rate (% of total enrollments) of Barbados in 2005 to that in 2010?
Provide a short and direct response. 0.92. What is the ratio of the Primary completion rate (% of total enrollments) in Burundi in 2005 to that in 2010?
Your answer should be compact. 0.73. What is the ratio of the Primary completion rate (% of total enrollments) of Cuba in 2005 to that in 2010?
Your answer should be compact. 0.94. What is the ratio of the Primary completion rate (% of total enrollments) in Barbados in 2007 to that in 2008?
Your answer should be very brief. 0.98. What is the ratio of the Primary completion rate (% of total enrollments) of Burundi in 2007 to that in 2008?
Your answer should be very brief. 0.94. What is the ratio of the Primary completion rate (% of total enrollments) in Cuba in 2007 to that in 2008?
Make the answer very short. 1.03. What is the ratio of the Primary completion rate (% of total enrollments) in Lower middle income in 2007 to that in 2009?
Offer a very short reply. 0.98. What is the ratio of the Primary completion rate (% of total enrollments) in Barbados in 2007 to that in 2009?
Keep it short and to the point. 0.96. What is the ratio of the Primary completion rate (% of total enrollments) of Burundi in 2007 to that in 2009?
Offer a very short reply. 0.84. What is the ratio of the Primary completion rate (% of total enrollments) in Cuba in 2007 to that in 2009?
Provide a short and direct response. 0.94. What is the ratio of the Primary completion rate (% of total enrollments) in Lower middle income in 2007 to that in 2010?
Give a very brief answer. 0.98. What is the ratio of the Primary completion rate (% of total enrollments) in Barbados in 2007 to that in 2010?
Offer a terse response. 0.95. What is the ratio of the Primary completion rate (% of total enrollments) in Burundi in 2007 to that in 2010?
Your answer should be compact. 0.8. What is the ratio of the Primary completion rate (% of total enrollments) of Cuba in 2007 to that in 2010?
Offer a terse response. 0.94. What is the ratio of the Primary completion rate (% of total enrollments) of Lower middle income in 2008 to that in 2009?
Ensure brevity in your answer.  0.99. What is the ratio of the Primary completion rate (% of total enrollments) of Barbados in 2008 to that in 2009?
Give a very brief answer. 0.98. What is the ratio of the Primary completion rate (% of total enrollments) of Burundi in 2008 to that in 2009?
Provide a short and direct response. 0.89. What is the ratio of the Primary completion rate (% of total enrollments) of Cuba in 2008 to that in 2009?
Make the answer very short. 0.91. What is the ratio of the Primary completion rate (% of total enrollments) of Lower middle income in 2008 to that in 2010?
Ensure brevity in your answer.  0.98. What is the ratio of the Primary completion rate (% of total enrollments) in Barbados in 2008 to that in 2010?
Your answer should be very brief. 0.97. What is the ratio of the Primary completion rate (% of total enrollments) of Burundi in 2008 to that in 2010?
Your response must be concise. 0.85. What is the ratio of the Primary completion rate (% of total enrollments) of Cuba in 2008 to that in 2010?
Provide a short and direct response. 0.91. What is the ratio of the Primary completion rate (% of total enrollments) in Lower middle income in 2009 to that in 2010?
Make the answer very short. 0.99. What is the ratio of the Primary completion rate (% of total enrollments) of Barbados in 2009 to that in 2010?
Offer a terse response. 0.99. What is the ratio of the Primary completion rate (% of total enrollments) in Burundi in 2009 to that in 2010?
Provide a succinct answer. 0.95. What is the difference between the highest and the second highest Primary completion rate (% of total enrollments) of Lower middle income?
Your answer should be very brief. 0.52. What is the difference between the highest and the second highest Primary completion rate (% of total enrollments) of Barbados?
Your answer should be compact. 6.33. What is the difference between the highest and the second highest Primary completion rate (% of total enrollments) of Burundi?
Offer a terse response. 2.55. What is the difference between the highest and the second highest Primary completion rate (% of total enrollments) of Cuba?
Provide a short and direct response. 0.08. What is the difference between the highest and the lowest Primary completion rate (% of total enrollments) of Lower middle income?
Offer a very short reply. 7.03. What is the difference between the highest and the lowest Primary completion rate (% of total enrollments) in Barbados?
Your answer should be compact. 15.3. What is the difference between the highest and the lowest Primary completion rate (% of total enrollments) in Burundi?
Provide a short and direct response. 18.81. What is the difference between the highest and the lowest Primary completion rate (% of total enrollments) in Cuba?
Provide a short and direct response. 9.07. 